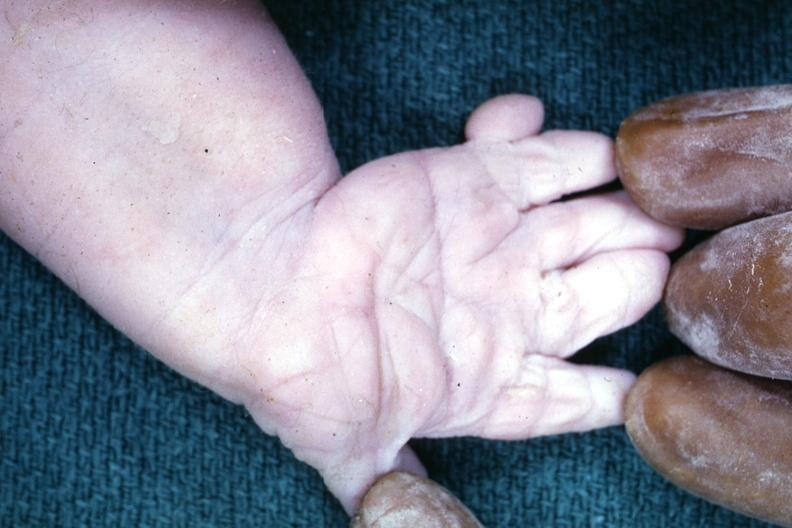does this image show simian crease?
Answer the question using a single word or phrase. Yes 